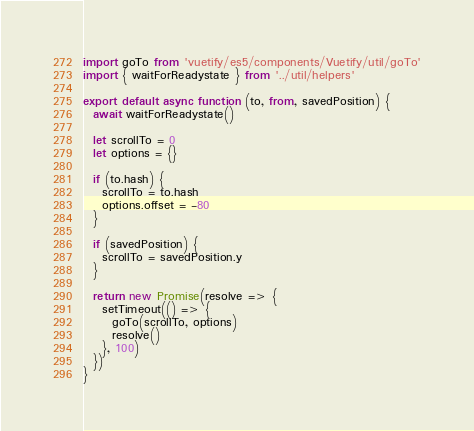Convert code to text. <code><loc_0><loc_0><loc_500><loc_500><_JavaScript_>import goTo from 'vuetify/es5/components/Vuetify/util/goTo'
import { waitForReadystate } from '../util/helpers'

export default async function (to, from, savedPosition) {
  await waitForReadystate()

  let scrollTo = 0
  let options = {}

  if (to.hash) {
    scrollTo = to.hash
    options.offset = -80
  }

  if (savedPosition) {
    scrollTo = savedPosition.y
  }

  return new Promise(resolve => {
    setTimeout(() => {
      goTo(scrollTo, options)
      resolve()
    }, 100)
  })
}
</code> 